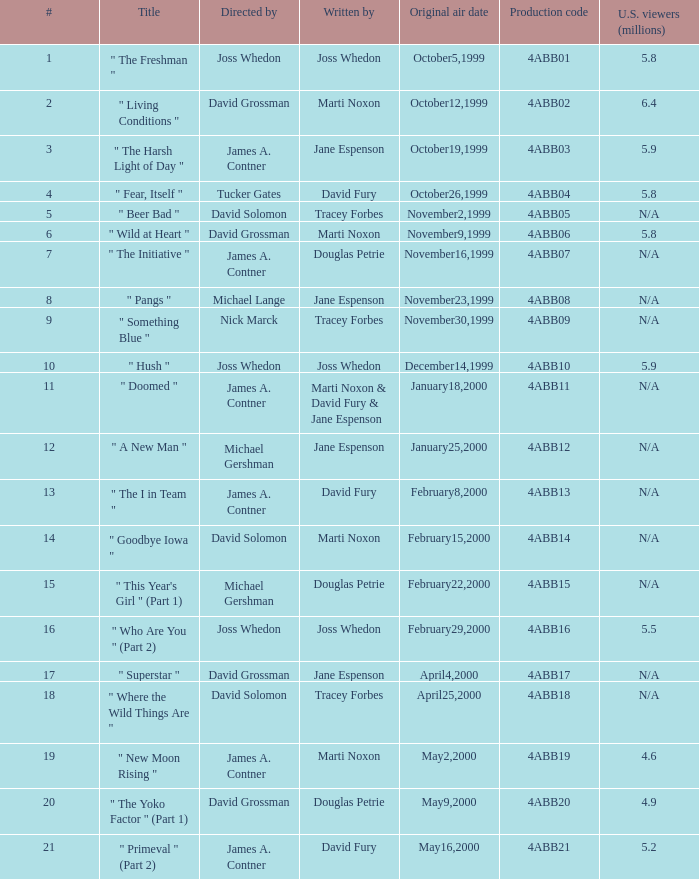What is the production code for the episode with 5.5 million u.s. viewers? 4ABB16. 